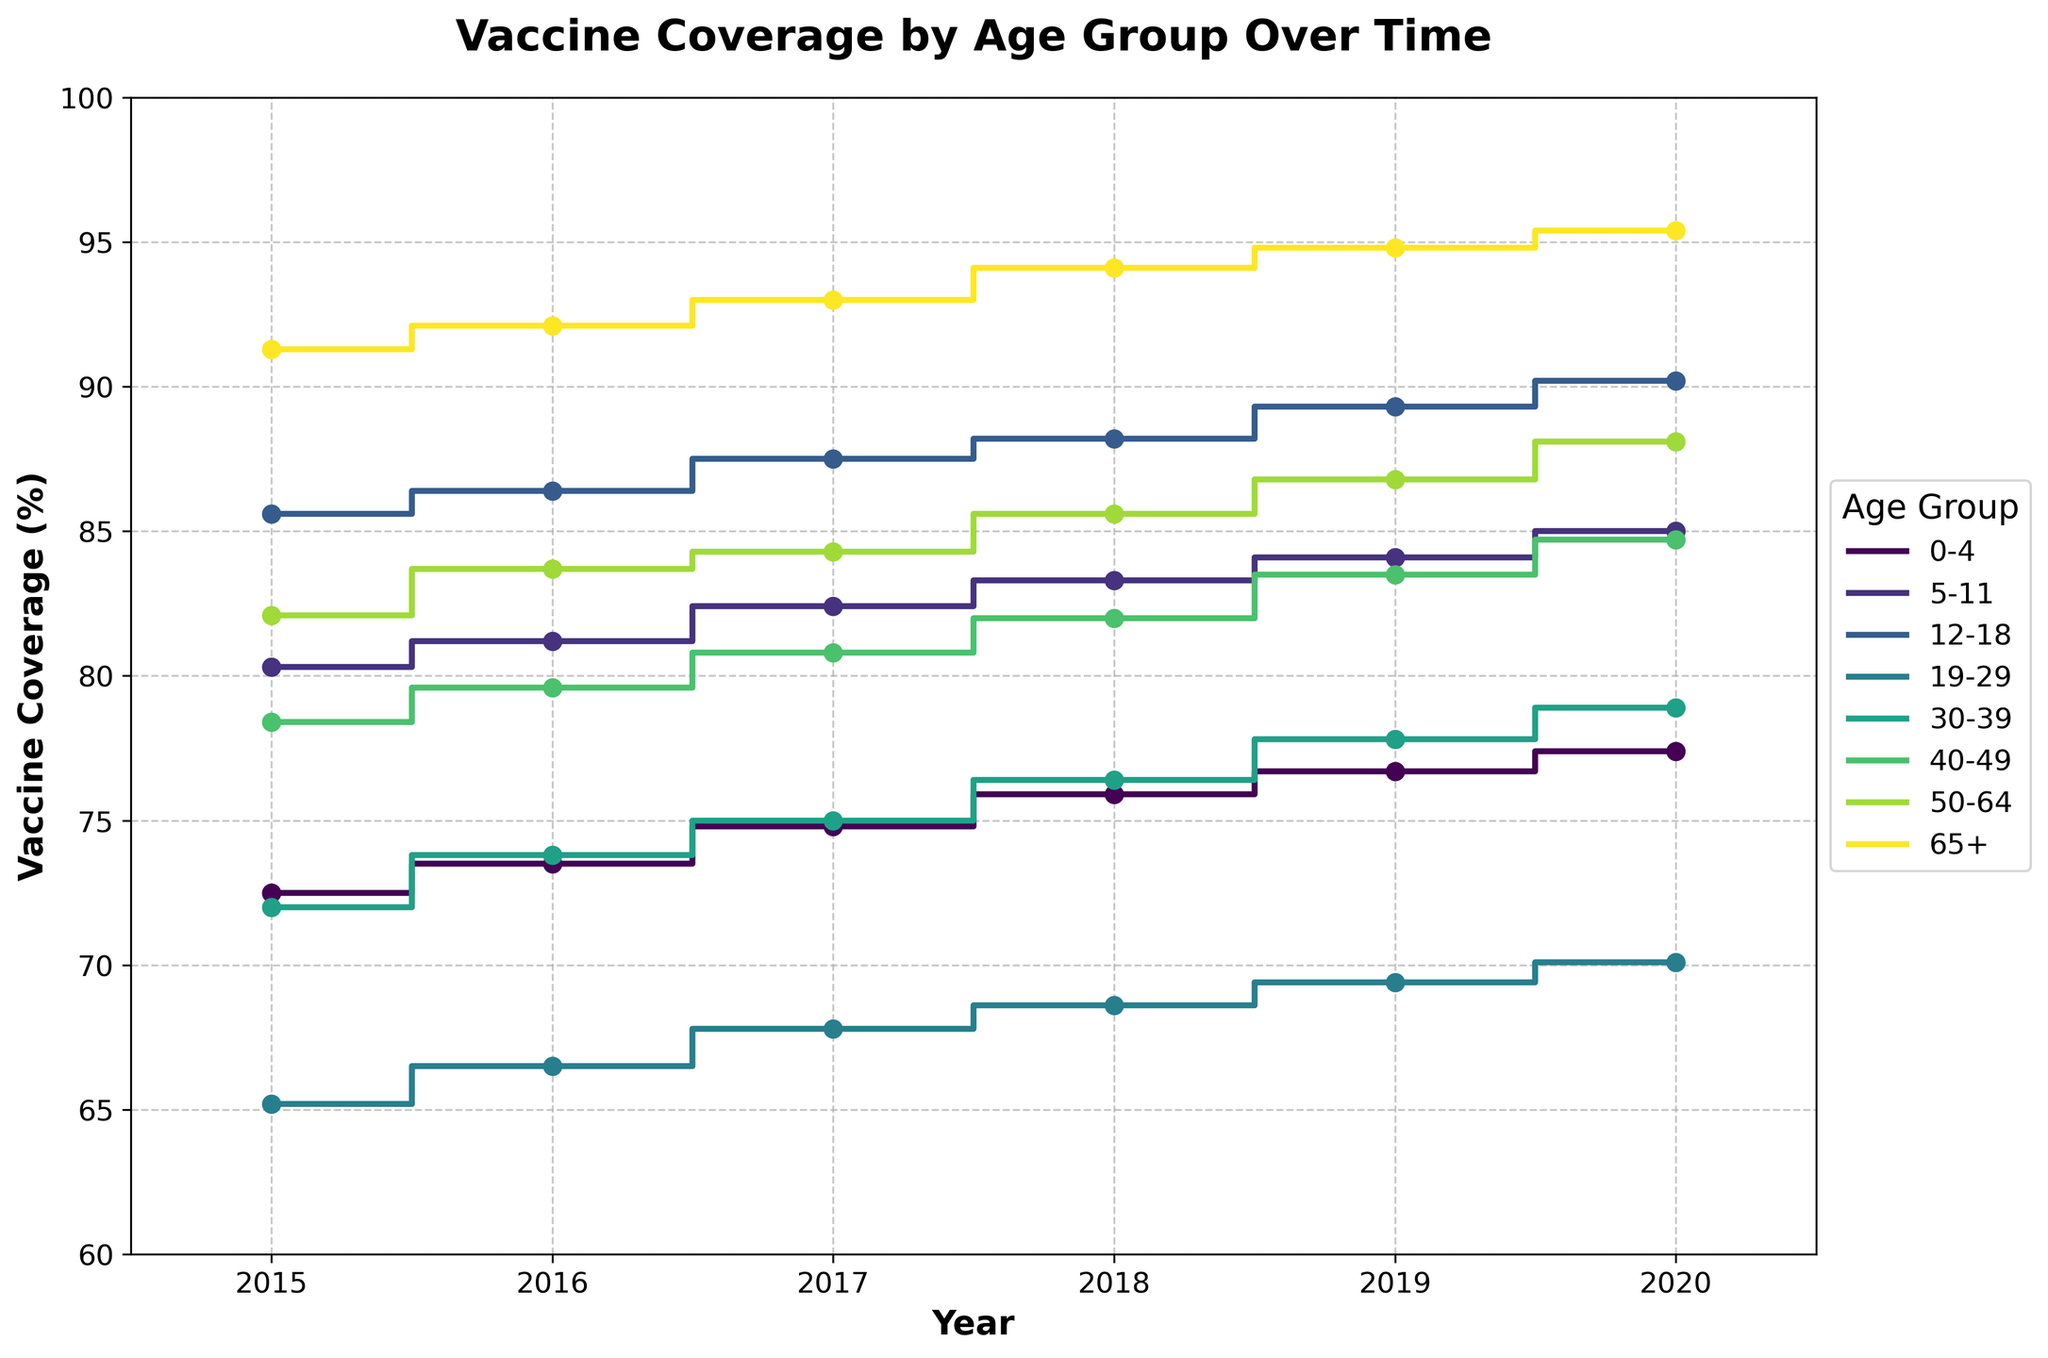What is the title of the figure? The title is generally located at the top of the figure. It describes the overall information the plot conveys. In this case, it states "Vaccine Coverage by Age Group Over Time."
Answer: Vaccine Coverage by Age Group Over Time Between which years does the data range in the plot? The X-axis represents years. Observing the start and end points on this axis, the data ranges from 2015 to 2020.
Answer: 2015 to 2020 Which age group has the highest vaccine coverage in 2020? Look at the endpoint of the 2020 data markers for each age group. The 65+ age group has the highest marker.
Answer: 65+ Which age group showed the largest increase in vaccine coverage from 2015 to 2020? Calculate the difference between vaccine coverage in 2020 and 2015 for each age group by checking their respective data points. The largest difference is found in the 50-64 age group (88.1 - 82.1 = 6.0).
Answer: 50-64 Compare the vaccine coverage of the 0-4 and 30-39 age groups in 2018. Which group had higher coverage? Examine the 2018 data points for 0-4 and 30-39 age groups. The coverage for 0-4 age group is 75.9% while for 30-39 it is 76.4%.
Answer: 30-39 By how much did the vaccine coverage for the 19-29 age group change from 2016 to 2019? Find the vaccine coverage for the 19-29 age group in 2016 and 2019, then subtract the earlier value from the later value (69.4 - 66.5 = 2.9).
Answer: 2.9% Which year shows the smallest vaccine coverage for the 40-49 age group? Look at all the data points for the 40-49 age group across all years and identify the lowest value, which is in 2015 with 78.4%.
Answer: 2015 Was there a consistent increase in vaccine coverage for the 12-18 age group from 2015 to 2020? Check the data points for the 12-18 age group from 2015 to 2020. Each subsequent year has a higher coverage than the previous one.
Answer: Yes Compare the trend of vaccine coverage over time between the 5-11 and 19-29 age groups. Which group shows more variability? Observe the step changes and the slope variability of the coverage lines for both age groups. The 19-29 age group shows more ups and downs compared to the relatively steady increase of the 5-11 group.
Answer: 19-29 What is the highest overall vaccine coverage recorded among all age groups and years in the plot? Identify the highest marker point across all data which is the 65+ age group in 2020 with 95.4%.
Answer: 95.4% 